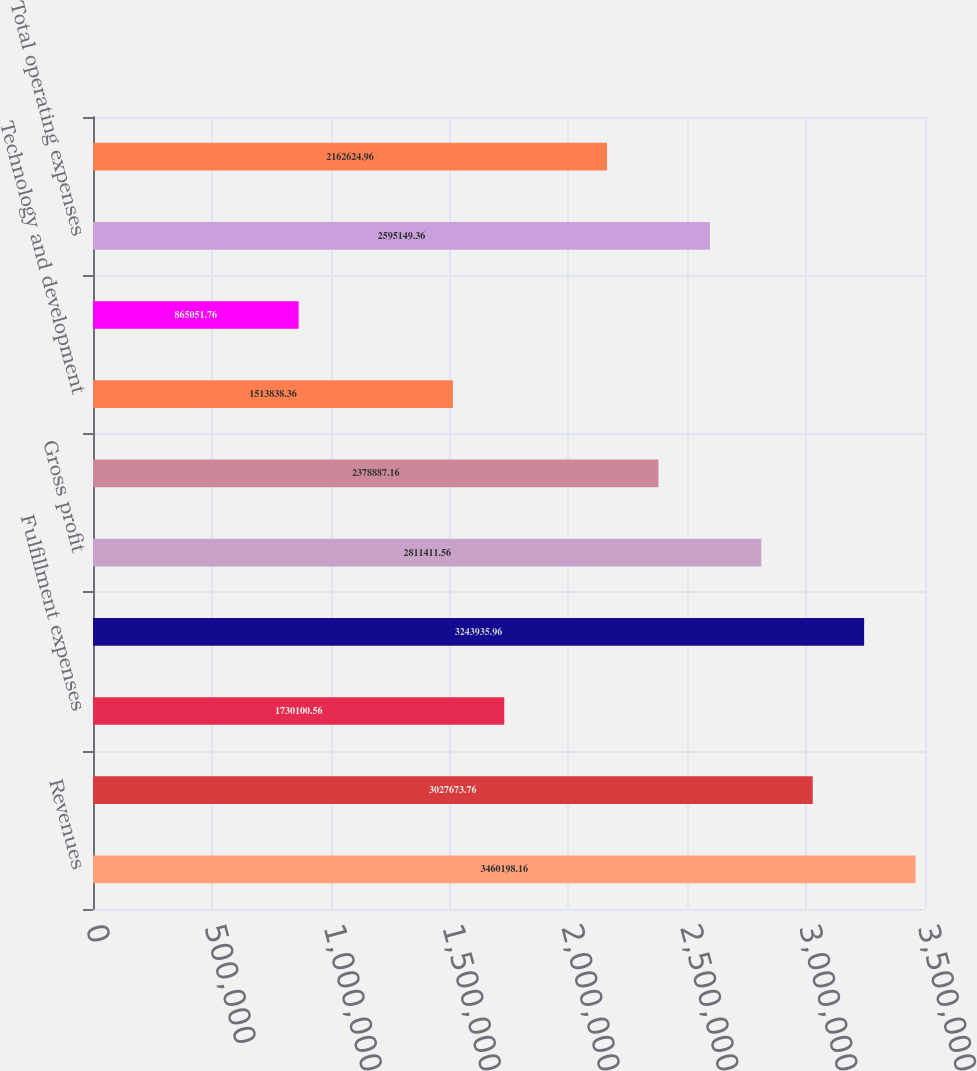<chart> <loc_0><loc_0><loc_500><loc_500><bar_chart><fcel>Revenues<fcel>Subscription<fcel>Fulfillment expenses<fcel>Total cost of revenues<fcel>Gross profit<fcel>Marketing<fcel>Technology and development<fcel>General and administrative<fcel>Total operating expenses<fcel>Operating income<nl><fcel>3.4602e+06<fcel>3.02767e+06<fcel>1.7301e+06<fcel>3.24394e+06<fcel>2.81141e+06<fcel>2.37889e+06<fcel>1.51384e+06<fcel>865052<fcel>2.59515e+06<fcel>2.16262e+06<nl></chart> 